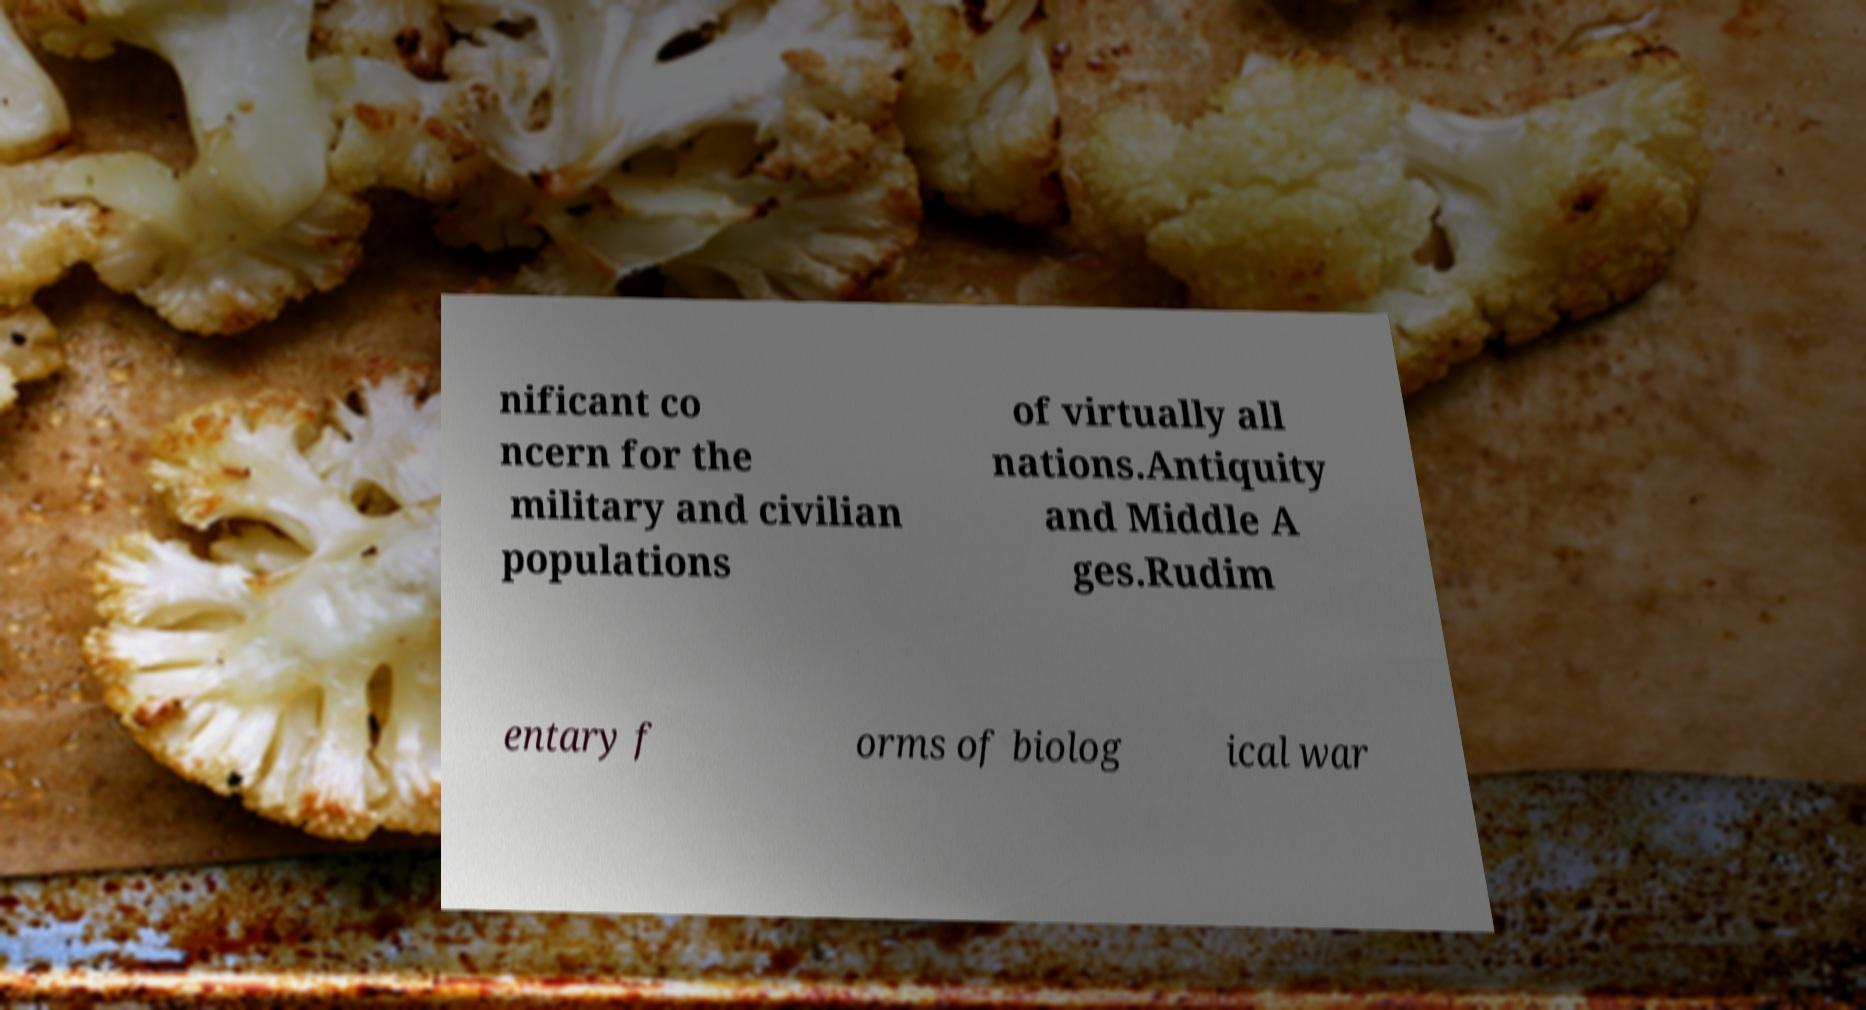For documentation purposes, I need the text within this image transcribed. Could you provide that? nificant co ncern for the military and civilian populations of virtually all nations.Antiquity and Middle A ges.Rudim entary f orms of biolog ical war 